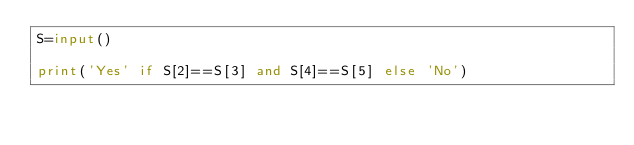Convert code to text. <code><loc_0><loc_0><loc_500><loc_500><_Python_>S=input()

print('Yes' if S[2]==S[3] and S[4]==S[5] else 'No')</code> 